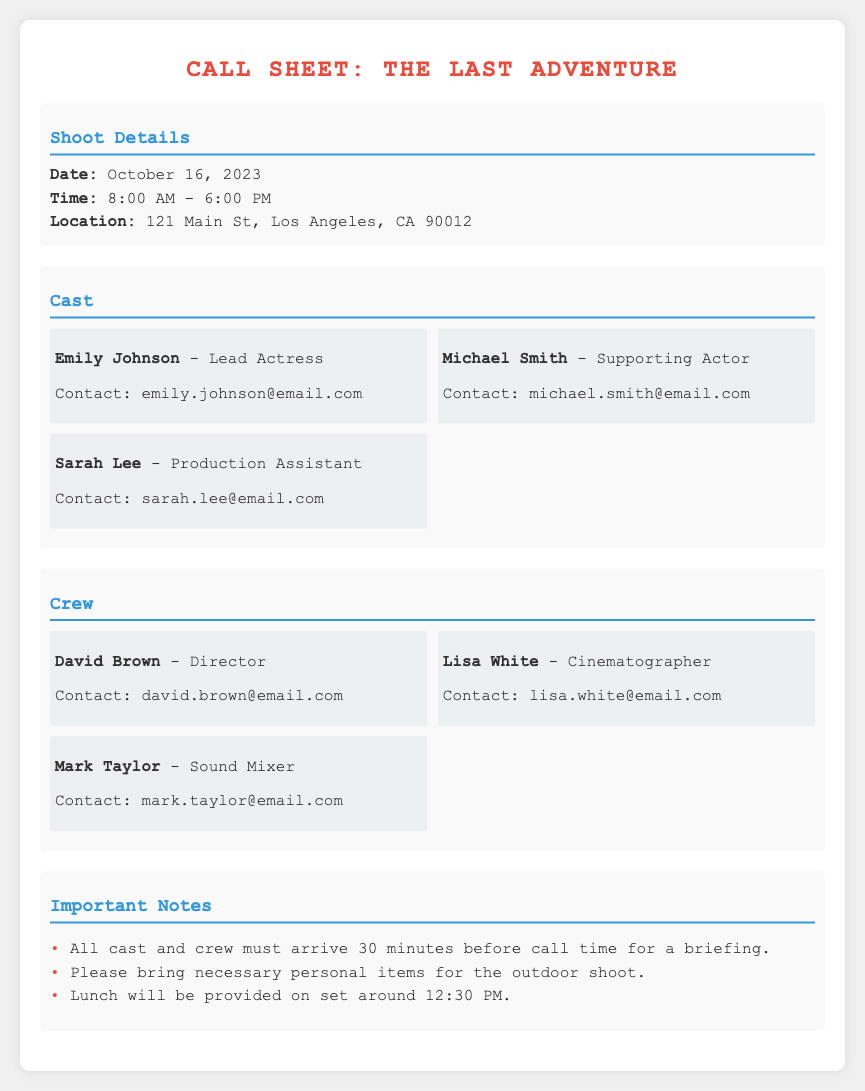What is the shoot date? The shoot date is mentioned directly in the details section of the document.
Answer: October 16, 2023 What time does the shoot start? The start time of the shoot is specified in the shoot details section.
Answer: 8:00 AM What is the location of the shoot? The location is listed under the shoot details.
Answer: 121 Main St, Los Angeles, CA 90012 Who is the lead actress? The name of the lead actress is found in the cast section.
Answer: Emily Johnson How many crew members are listed? The total number of crew members can be found by counting the individuals in the crew section.
Answer: 3 What is the role of David Brown? David Brown’s role is detailed in the crew section of the document.
Answer: Director What time will lunch be provided? Lunch time is specified under the important notes section of the document.
Answer: 12:30 PM What should all cast and crew do before call time? The instructions regarding arrival time are listed in the important notes.
Answer: Arrive 30 minutes early Who is responsible for sound mixing? The sound mixer’s name is found in the crew section of the document.
Answer: Mark Taylor 